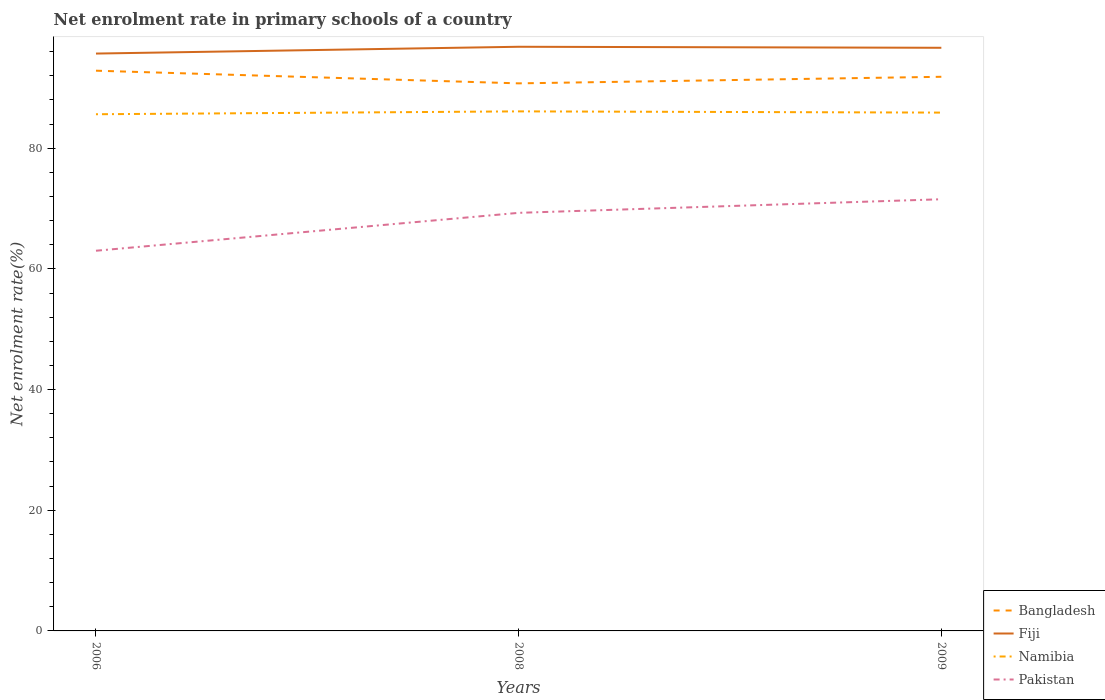Does the line corresponding to Namibia intersect with the line corresponding to Fiji?
Keep it short and to the point. No. Across all years, what is the maximum net enrolment rate in primary schools in Bangladesh?
Offer a very short reply. 90.75. What is the total net enrolment rate in primary schools in Bangladesh in the graph?
Your answer should be very brief. 2.1. What is the difference between the highest and the second highest net enrolment rate in primary schools in Namibia?
Provide a succinct answer. 0.48. How many lines are there?
Keep it short and to the point. 4. Are the values on the major ticks of Y-axis written in scientific E-notation?
Offer a very short reply. No. Does the graph contain any zero values?
Your response must be concise. No. Does the graph contain grids?
Your response must be concise. No. How are the legend labels stacked?
Keep it short and to the point. Vertical. What is the title of the graph?
Offer a very short reply. Net enrolment rate in primary schools of a country. What is the label or title of the X-axis?
Your answer should be compact. Years. What is the label or title of the Y-axis?
Your answer should be compact. Net enrolment rate(%). What is the Net enrolment rate(%) of Bangladesh in 2006?
Provide a succinct answer. 92.85. What is the Net enrolment rate(%) of Fiji in 2006?
Offer a very short reply. 95.69. What is the Net enrolment rate(%) in Namibia in 2006?
Provide a succinct answer. 85.64. What is the Net enrolment rate(%) in Pakistan in 2006?
Give a very brief answer. 63.01. What is the Net enrolment rate(%) in Bangladesh in 2008?
Your response must be concise. 90.75. What is the Net enrolment rate(%) in Fiji in 2008?
Ensure brevity in your answer.  96.82. What is the Net enrolment rate(%) in Namibia in 2008?
Your answer should be very brief. 86.11. What is the Net enrolment rate(%) in Pakistan in 2008?
Provide a succinct answer. 69.29. What is the Net enrolment rate(%) of Bangladesh in 2009?
Offer a very short reply. 91.84. What is the Net enrolment rate(%) in Fiji in 2009?
Give a very brief answer. 96.65. What is the Net enrolment rate(%) of Namibia in 2009?
Offer a terse response. 85.91. What is the Net enrolment rate(%) in Pakistan in 2009?
Offer a very short reply. 71.55. Across all years, what is the maximum Net enrolment rate(%) in Bangladesh?
Your answer should be very brief. 92.85. Across all years, what is the maximum Net enrolment rate(%) in Fiji?
Give a very brief answer. 96.82. Across all years, what is the maximum Net enrolment rate(%) in Namibia?
Provide a short and direct response. 86.11. Across all years, what is the maximum Net enrolment rate(%) of Pakistan?
Ensure brevity in your answer.  71.55. Across all years, what is the minimum Net enrolment rate(%) in Bangladesh?
Give a very brief answer. 90.75. Across all years, what is the minimum Net enrolment rate(%) of Fiji?
Your response must be concise. 95.69. Across all years, what is the minimum Net enrolment rate(%) in Namibia?
Your response must be concise. 85.64. Across all years, what is the minimum Net enrolment rate(%) in Pakistan?
Ensure brevity in your answer.  63.01. What is the total Net enrolment rate(%) of Bangladesh in the graph?
Ensure brevity in your answer.  275.45. What is the total Net enrolment rate(%) in Fiji in the graph?
Make the answer very short. 289.16. What is the total Net enrolment rate(%) of Namibia in the graph?
Your answer should be very brief. 257.66. What is the total Net enrolment rate(%) of Pakistan in the graph?
Keep it short and to the point. 203.85. What is the difference between the Net enrolment rate(%) of Bangladesh in 2006 and that in 2008?
Your answer should be compact. 2.1. What is the difference between the Net enrolment rate(%) of Fiji in 2006 and that in 2008?
Your answer should be very brief. -1.13. What is the difference between the Net enrolment rate(%) in Namibia in 2006 and that in 2008?
Give a very brief answer. -0.48. What is the difference between the Net enrolment rate(%) of Pakistan in 2006 and that in 2008?
Give a very brief answer. -6.28. What is the difference between the Net enrolment rate(%) in Bangladesh in 2006 and that in 2009?
Make the answer very short. 1.01. What is the difference between the Net enrolment rate(%) in Fiji in 2006 and that in 2009?
Your response must be concise. -0.96. What is the difference between the Net enrolment rate(%) of Namibia in 2006 and that in 2009?
Make the answer very short. -0.27. What is the difference between the Net enrolment rate(%) of Pakistan in 2006 and that in 2009?
Provide a short and direct response. -8.53. What is the difference between the Net enrolment rate(%) in Bangladesh in 2008 and that in 2009?
Offer a terse response. -1.09. What is the difference between the Net enrolment rate(%) of Fiji in 2008 and that in 2009?
Provide a succinct answer. 0.17. What is the difference between the Net enrolment rate(%) of Namibia in 2008 and that in 2009?
Your response must be concise. 0.2. What is the difference between the Net enrolment rate(%) of Pakistan in 2008 and that in 2009?
Your answer should be compact. -2.25. What is the difference between the Net enrolment rate(%) in Bangladesh in 2006 and the Net enrolment rate(%) in Fiji in 2008?
Your answer should be very brief. -3.96. What is the difference between the Net enrolment rate(%) of Bangladesh in 2006 and the Net enrolment rate(%) of Namibia in 2008?
Offer a very short reply. 6.74. What is the difference between the Net enrolment rate(%) in Bangladesh in 2006 and the Net enrolment rate(%) in Pakistan in 2008?
Offer a terse response. 23.56. What is the difference between the Net enrolment rate(%) of Fiji in 2006 and the Net enrolment rate(%) of Namibia in 2008?
Provide a short and direct response. 9.58. What is the difference between the Net enrolment rate(%) in Fiji in 2006 and the Net enrolment rate(%) in Pakistan in 2008?
Your answer should be very brief. 26.4. What is the difference between the Net enrolment rate(%) of Namibia in 2006 and the Net enrolment rate(%) of Pakistan in 2008?
Offer a terse response. 16.34. What is the difference between the Net enrolment rate(%) of Bangladesh in 2006 and the Net enrolment rate(%) of Fiji in 2009?
Ensure brevity in your answer.  -3.8. What is the difference between the Net enrolment rate(%) in Bangladesh in 2006 and the Net enrolment rate(%) in Namibia in 2009?
Provide a short and direct response. 6.95. What is the difference between the Net enrolment rate(%) in Bangladesh in 2006 and the Net enrolment rate(%) in Pakistan in 2009?
Offer a very short reply. 21.31. What is the difference between the Net enrolment rate(%) in Fiji in 2006 and the Net enrolment rate(%) in Namibia in 2009?
Provide a short and direct response. 9.78. What is the difference between the Net enrolment rate(%) of Fiji in 2006 and the Net enrolment rate(%) of Pakistan in 2009?
Keep it short and to the point. 24.15. What is the difference between the Net enrolment rate(%) of Namibia in 2006 and the Net enrolment rate(%) of Pakistan in 2009?
Ensure brevity in your answer.  14.09. What is the difference between the Net enrolment rate(%) in Bangladesh in 2008 and the Net enrolment rate(%) in Fiji in 2009?
Keep it short and to the point. -5.9. What is the difference between the Net enrolment rate(%) in Bangladesh in 2008 and the Net enrolment rate(%) in Namibia in 2009?
Give a very brief answer. 4.85. What is the difference between the Net enrolment rate(%) of Bangladesh in 2008 and the Net enrolment rate(%) of Pakistan in 2009?
Make the answer very short. 19.21. What is the difference between the Net enrolment rate(%) of Fiji in 2008 and the Net enrolment rate(%) of Namibia in 2009?
Your answer should be compact. 10.91. What is the difference between the Net enrolment rate(%) in Fiji in 2008 and the Net enrolment rate(%) in Pakistan in 2009?
Ensure brevity in your answer.  25.27. What is the difference between the Net enrolment rate(%) in Namibia in 2008 and the Net enrolment rate(%) in Pakistan in 2009?
Provide a succinct answer. 14.57. What is the average Net enrolment rate(%) in Bangladesh per year?
Give a very brief answer. 91.82. What is the average Net enrolment rate(%) in Fiji per year?
Keep it short and to the point. 96.39. What is the average Net enrolment rate(%) of Namibia per year?
Your answer should be very brief. 85.89. What is the average Net enrolment rate(%) of Pakistan per year?
Ensure brevity in your answer.  67.95. In the year 2006, what is the difference between the Net enrolment rate(%) in Bangladesh and Net enrolment rate(%) in Fiji?
Offer a very short reply. -2.84. In the year 2006, what is the difference between the Net enrolment rate(%) in Bangladesh and Net enrolment rate(%) in Namibia?
Provide a succinct answer. 7.22. In the year 2006, what is the difference between the Net enrolment rate(%) of Bangladesh and Net enrolment rate(%) of Pakistan?
Your answer should be compact. 29.84. In the year 2006, what is the difference between the Net enrolment rate(%) of Fiji and Net enrolment rate(%) of Namibia?
Provide a succinct answer. 10.06. In the year 2006, what is the difference between the Net enrolment rate(%) of Fiji and Net enrolment rate(%) of Pakistan?
Offer a terse response. 32.68. In the year 2006, what is the difference between the Net enrolment rate(%) of Namibia and Net enrolment rate(%) of Pakistan?
Make the answer very short. 22.62. In the year 2008, what is the difference between the Net enrolment rate(%) of Bangladesh and Net enrolment rate(%) of Fiji?
Ensure brevity in your answer.  -6.06. In the year 2008, what is the difference between the Net enrolment rate(%) in Bangladesh and Net enrolment rate(%) in Namibia?
Your response must be concise. 4.64. In the year 2008, what is the difference between the Net enrolment rate(%) in Bangladesh and Net enrolment rate(%) in Pakistan?
Your answer should be compact. 21.46. In the year 2008, what is the difference between the Net enrolment rate(%) in Fiji and Net enrolment rate(%) in Namibia?
Make the answer very short. 10.71. In the year 2008, what is the difference between the Net enrolment rate(%) of Fiji and Net enrolment rate(%) of Pakistan?
Give a very brief answer. 27.52. In the year 2008, what is the difference between the Net enrolment rate(%) in Namibia and Net enrolment rate(%) in Pakistan?
Your response must be concise. 16.82. In the year 2009, what is the difference between the Net enrolment rate(%) in Bangladesh and Net enrolment rate(%) in Fiji?
Offer a very short reply. -4.81. In the year 2009, what is the difference between the Net enrolment rate(%) in Bangladesh and Net enrolment rate(%) in Namibia?
Your answer should be compact. 5.94. In the year 2009, what is the difference between the Net enrolment rate(%) of Bangladesh and Net enrolment rate(%) of Pakistan?
Give a very brief answer. 20.3. In the year 2009, what is the difference between the Net enrolment rate(%) in Fiji and Net enrolment rate(%) in Namibia?
Offer a terse response. 10.74. In the year 2009, what is the difference between the Net enrolment rate(%) in Fiji and Net enrolment rate(%) in Pakistan?
Offer a terse response. 25.1. In the year 2009, what is the difference between the Net enrolment rate(%) in Namibia and Net enrolment rate(%) in Pakistan?
Offer a terse response. 14.36. What is the ratio of the Net enrolment rate(%) in Bangladesh in 2006 to that in 2008?
Keep it short and to the point. 1.02. What is the ratio of the Net enrolment rate(%) of Fiji in 2006 to that in 2008?
Your response must be concise. 0.99. What is the ratio of the Net enrolment rate(%) of Namibia in 2006 to that in 2008?
Your answer should be very brief. 0.99. What is the ratio of the Net enrolment rate(%) in Pakistan in 2006 to that in 2008?
Your response must be concise. 0.91. What is the ratio of the Net enrolment rate(%) of Fiji in 2006 to that in 2009?
Your answer should be very brief. 0.99. What is the ratio of the Net enrolment rate(%) in Pakistan in 2006 to that in 2009?
Provide a succinct answer. 0.88. What is the ratio of the Net enrolment rate(%) in Fiji in 2008 to that in 2009?
Provide a short and direct response. 1. What is the ratio of the Net enrolment rate(%) of Pakistan in 2008 to that in 2009?
Your response must be concise. 0.97. What is the difference between the highest and the second highest Net enrolment rate(%) in Bangladesh?
Offer a very short reply. 1.01. What is the difference between the highest and the second highest Net enrolment rate(%) of Fiji?
Provide a succinct answer. 0.17. What is the difference between the highest and the second highest Net enrolment rate(%) of Namibia?
Provide a succinct answer. 0.2. What is the difference between the highest and the second highest Net enrolment rate(%) in Pakistan?
Make the answer very short. 2.25. What is the difference between the highest and the lowest Net enrolment rate(%) of Bangladesh?
Provide a short and direct response. 2.1. What is the difference between the highest and the lowest Net enrolment rate(%) of Fiji?
Offer a terse response. 1.13. What is the difference between the highest and the lowest Net enrolment rate(%) of Namibia?
Your answer should be very brief. 0.48. What is the difference between the highest and the lowest Net enrolment rate(%) of Pakistan?
Your response must be concise. 8.53. 